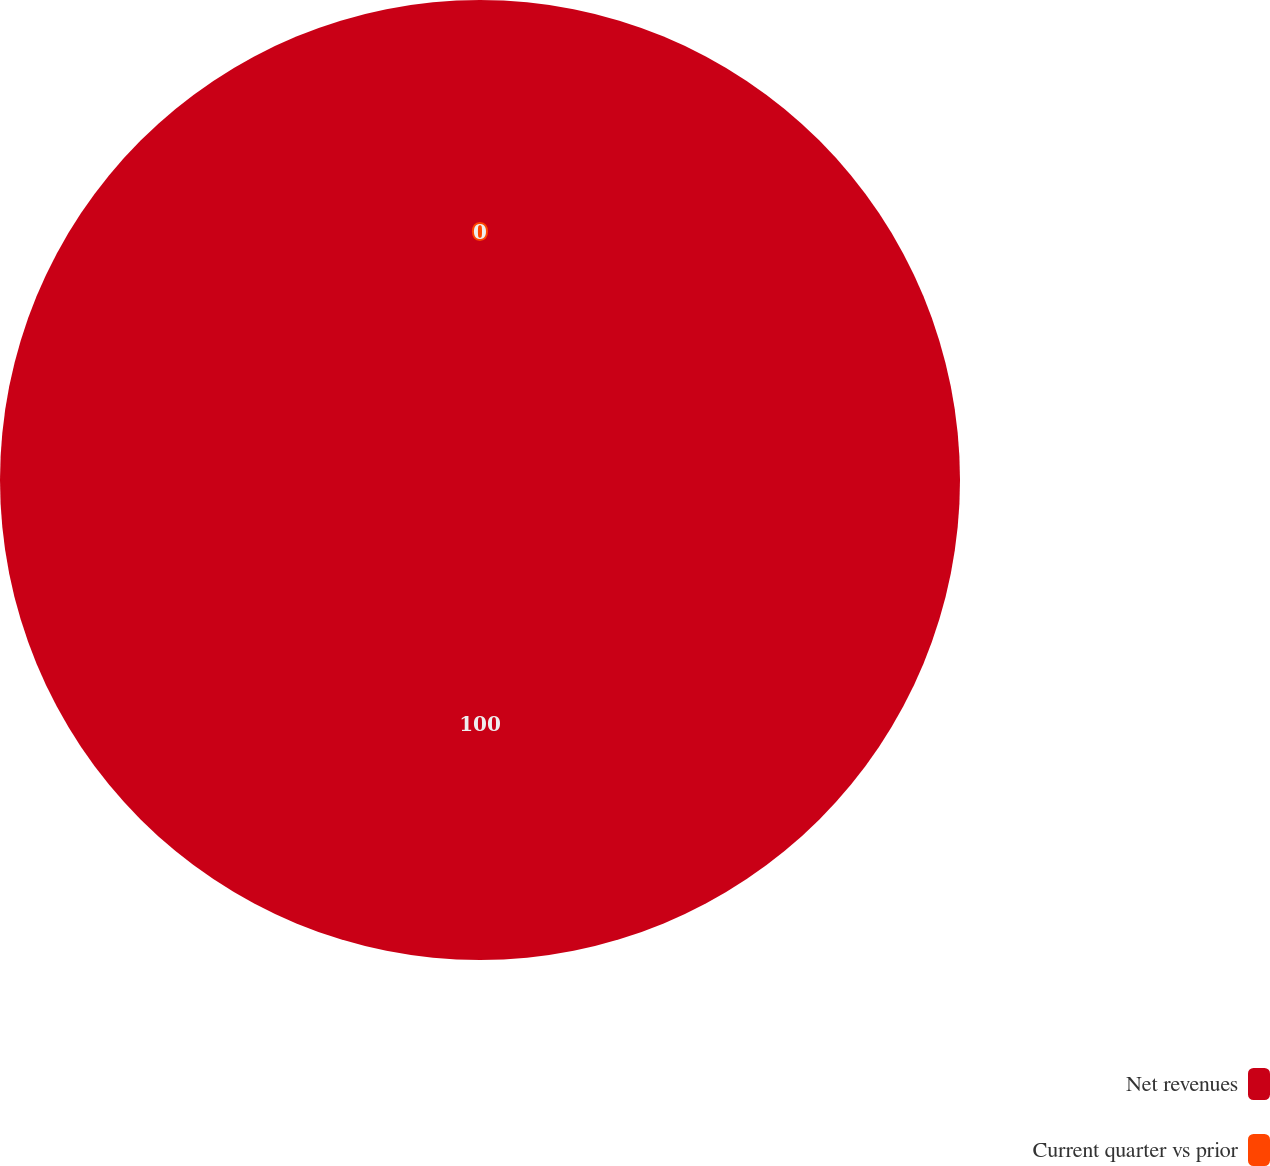Convert chart. <chart><loc_0><loc_0><loc_500><loc_500><pie_chart><fcel>Net revenues<fcel>Current quarter vs prior<nl><fcel>100.0%<fcel>0.0%<nl></chart> 